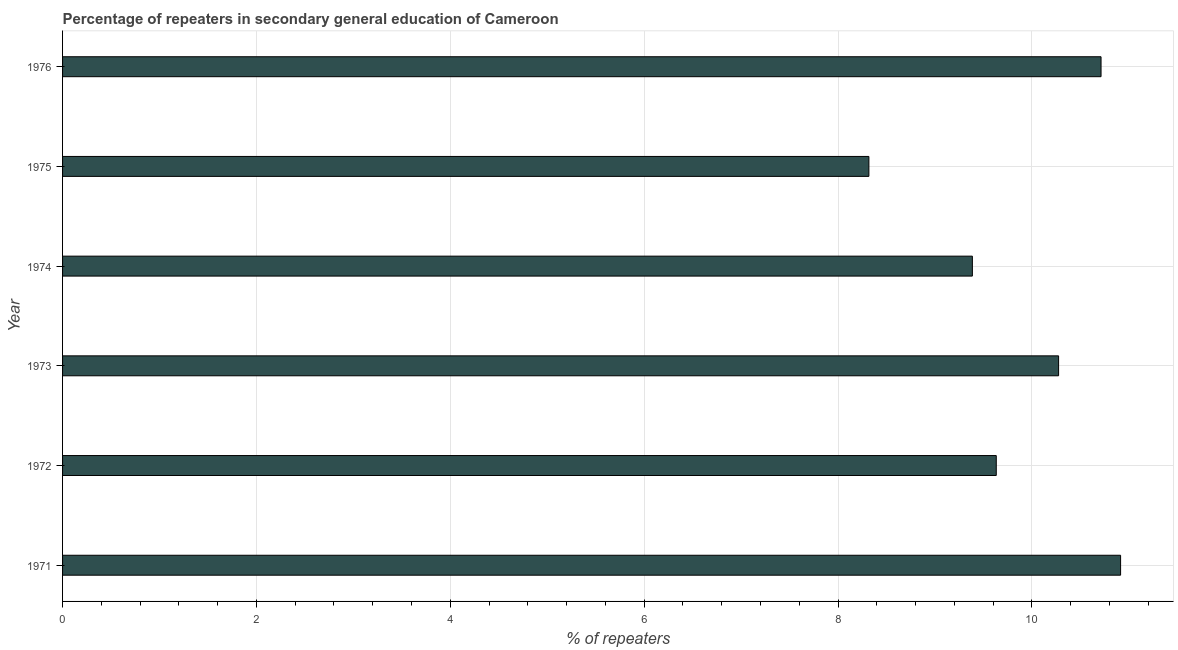What is the title of the graph?
Offer a terse response. Percentage of repeaters in secondary general education of Cameroon. What is the label or title of the X-axis?
Give a very brief answer. % of repeaters. What is the percentage of repeaters in 1972?
Offer a terse response. 9.63. Across all years, what is the maximum percentage of repeaters?
Give a very brief answer. 10.92. Across all years, what is the minimum percentage of repeaters?
Keep it short and to the point. 8.32. In which year was the percentage of repeaters maximum?
Your response must be concise. 1971. In which year was the percentage of repeaters minimum?
Your answer should be compact. 1975. What is the sum of the percentage of repeaters?
Offer a terse response. 59.24. What is the difference between the percentage of repeaters in 1971 and 1973?
Provide a short and direct response. 0.64. What is the average percentage of repeaters per year?
Offer a terse response. 9.87. What is the median percentage of repeaters?
Offer a very short reply. 9.95. In how many years, is the percentage of repeaters greater than 10 %?
Keep it short and to the point. 3. What is the ratio of the percentage of repeaters in 1971 to that in 1972?
Keep it short and to the point. 1.13. Is the difference between the percentage of repeaters in 1972 and 1974 greater than the difference between any two years?
Offer a terse response. No. What is the difference between the highest and the second highest percentage of repeaters?
Provide a succinct answer. 0.2. What is the difference between the highest and the lowest percentage of repeaters?
Provide a short and direct response. 2.6. In how many years, is the percentage of repeaters greater than the average percentage of repeaters taken over all years?
Keep it short and to the point. 3. How many bars are there?
Make the answer very short. 6. Are all the bars in the graph horizontal?
Provide a short and direct response. Yes. How many years are there in the graph?
Make the answer very short. 6. What is the difference between two consecutive major ticks on the X-axis?
Your answer should be compact. 2. Are the values on the major ticks of X-axis written in scientific E-notation?
Ensure brevity in your answer.  No. What is the % of repeaters of 1971?
Provide a succinct answer. 10.92. What is the % of repeaters in 1972?
Give a very brief answer. 9.63. What is the % of repeaters in 1973?
Make the answer very short. 10.28. What is the % of repeaters in 1974?
Offer a terse response. 9.39. What is the % of repeaters in 1975?
Your answer should be compact. 8.32. What is the % of repeaters in 1976?
Ensure brevity in your answer.  10.71. What is the difference between the % of repeaters in 1971 and 1972?
Keep it short and to the point. 1.28. What is the difference between the % of repeaters in 1971 and 1973?
Provide a short and direct response. 0.64. What is the difference between the % of repeaters in 1971 and 1974?
Provide a short and direct response. 1.53. What is the difference between the % of repeaters in 1971 and 1975?
Offer a very short reply. 2.6. What is the difference between the % of repeaters in 1971 and 1976?
Make the answer very short. 0.2. What is the difference between the % of repeaters in 1972 and 1973?
Provide a succinct answer. -0.64. What is the difference between the % of repeaters in 1972 and 1974?
Offer a very short reply. 0.25. What is the difference between the % of repeaters in 1972 and 1975?
Ensure brevity in your answer.  1.31. What is the difference between the % of repeaters in 1972 and 1976?
Keep it short and to the point. -1.08. What is the difference between the % of repeaters in 1973 and 1974?
Provide a succinct answer. 0.89. What is the difference between the % of repeaters in 1973 and 1975?
Your response must be concise. 1.96. What is the difference between the % of repeaters in 1973 and 1976?
Your response must be concise. -0.44. What is the difference between the % of repeaters in 1974 and 1975?
Your answer should be very brief. 1.07. What is the difference between the % of repeaters in 1974 and 1976?
Keep it short and to the point. -1.33. What is the difference between the % of repeaters in 1975 and 1976?
Provide a short and direct response. -2.4. What is the ratio of the % of repeaters in 1971 to that in 1972?
Your answer should be very brief. 1.13. What is the ratio of the % of repeaters in 1971 to that in 1973?
Your answer should be very brief. 1.06. What is the ratio of the % of repeaters in 1971 to that in 1974?
Offer a terse response. 1.16. What is the ratio of the % of repeaters in 1971 to that in 1975?
Provide a succinct answer. 1.31. What is the ratio of the % of repeaters in 1971 to that in 1976?
Your answer should be compact. 1.02. What is the ratio of the % of repeaters in 1972 to that in 1973?
Give a very brief answer. 0.94. What is the ratio of the % of repeaters in 1972 to that in 1975?
Provide a short and direct response. 1.16. What is the ratio of the % of repeaters in 1972 to that in 1976?
Offer a terse response. 0.9. What is the ratio of the % of repeaters in 1973 to that in 1974?
Give a very brief answer. 1.09. What is the ratio of the % of repeaters in 1973 to that in 1975?
Provide a short and direct response. 1.24. What is the ratio of the % of repeaters in 1974 to that in 1975?
Your answer should be compact. 1.13. What is the ratio of the % of repeaters in 1974 to that in 1976?
Provide a short and direct response. 0.88. What is the ratio of the % of repeaters in 1975 to that in 1976?
Provide a short and direct response. 0.78. 